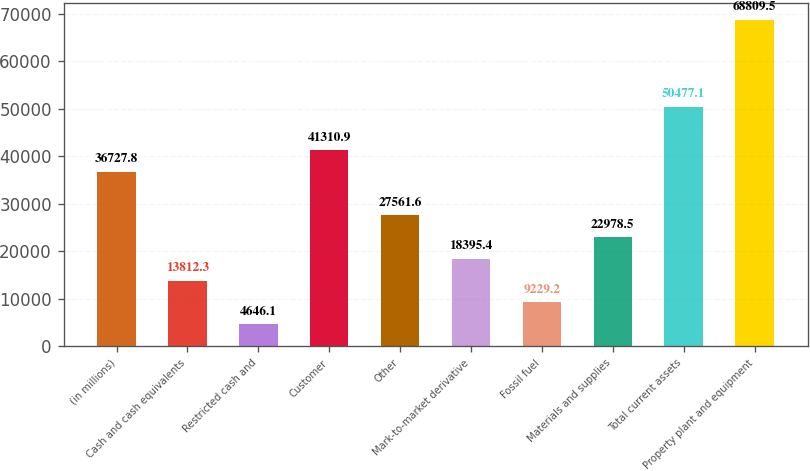Convert chart to OTSL. <chart><loc_0><loc_0><loc_500><loc_500><bar_chart><fcel>(in millions)<fcel>Cash and cash equivalents<fcel>Restricted cash and<fcel>Customer<fcel>Other<fcel>Mark-to-market derivative<fcel>Fossil fuel<fcel>Materials and supplies<fcel>Total current assets<fcel>Property plant and equipment<nl><fcel>36727.8<fcel>13812.3<fcel>4646.1<fcel>41310.9<fcel>27561.6<fcel>18395.4<fcel>9229.2<fcel>22978.5<fcel>50477.1<fcel>68809.5<nl></chart> 